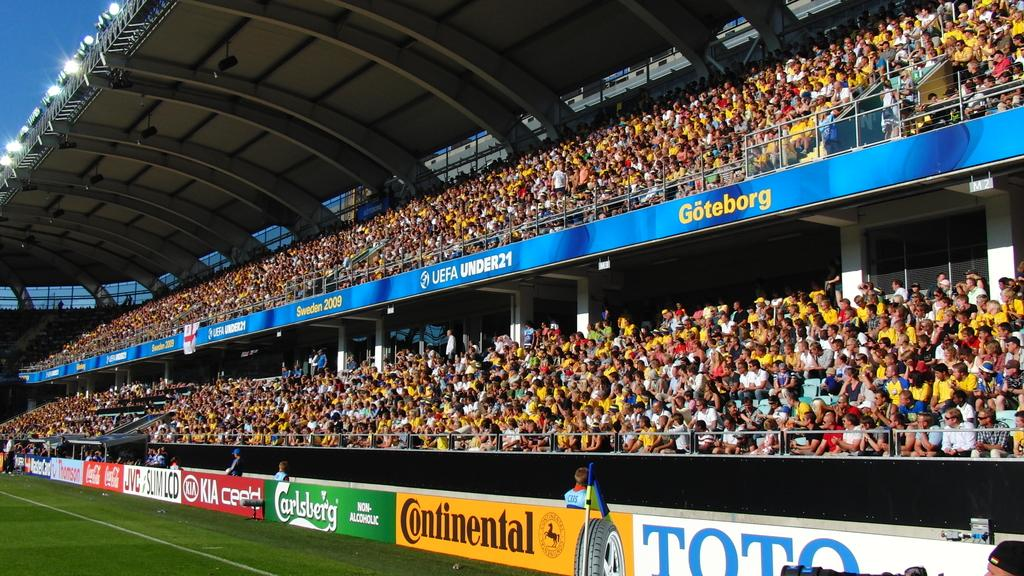<image>
Render a clear and concise summary of the photo. A crowded sports stadium with advertisements from Continental and Carlsberg. 